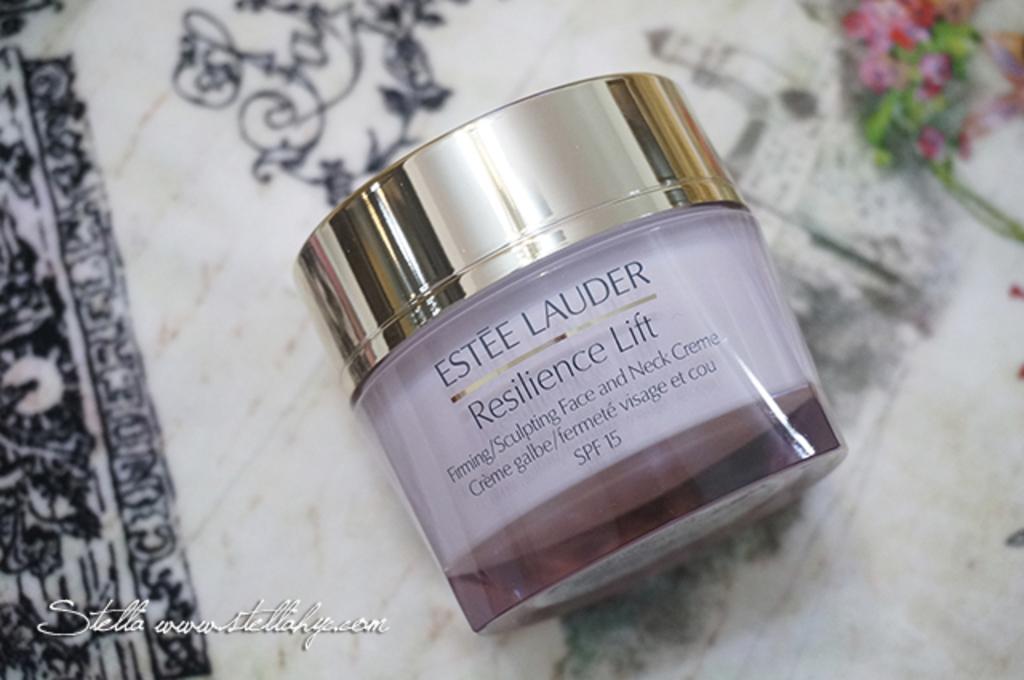Which brand is found here?
Make the answer very short. Estee lauder. 